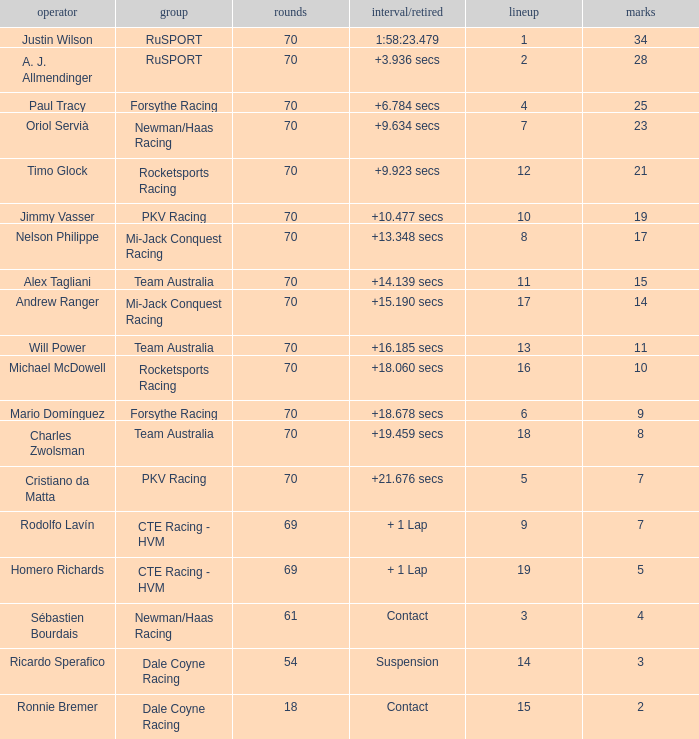Who scored with a grid of 10 and the highest amount of laps? 70.0. Can you give me this table as a dict? {'header': ['operator', 'group', 'rounds', 'interval/retired', 'lineup', 'marks'], 'rows': [['Justin Wilson', 'RuSPORT', '70', '1:58:23.479', '1', '34'], ['A. J. Allmendinger', 'RuSPORT', '70', '+3.936 secs', '2', '28'], ['Paul Tracy', 'Forsythe Racing', '70', '+6.784 secs', '4', '25'], ['Oriol Servià', 'Newman/Haas Racing', '70', '+9.634 secs', '7', '23'], ['Timo Glock', 'Rocketsports Racing', '70', '+9.923 secs', '12', '21'], ['Jimmy Vasser', 'PKV Racing', '70', '+10.477 secs', '10', '19'], ['Nelson Philippe', 'Mi-Jack Conquest Racing', '70', '+13.348 secs', '8', '17'], ['Alex Tagliani', 'Team Australia', '70', '+14.139 secs', '11', '15'], ['Andrew Ranger', 'Mi-Jack Conquest Racing', '70', '+15.190 secs', '17', '14'], ['Will Power', 'Team Australia', '70', '+16.185 secs', '13', '11'], ['Michael McDowell', 'Rocketsports Racing', '70', '+18.060 secs', '16', '10'], ['Mario Domínguez', 'Forsythe Racing', '70', '+18.678 secs', '6', '9'], ['Charles Zwolsman', 'Team Australia', '70', '+19.459 secs', '18', '8'], ['Cristiano da Matta', 'PKV Racing', '70', '+21.676 secs', '5', '7'], ['Rodolfo Lavín', 'CTE Racing - HVM', '69', '+ 1 Lap', '9', '7'], ['Homero Richards', 'CTE Racing - HVM', '69', '+ 1 Lap', '19', '5'], ['Sébastien Bourdais', 'Newman/Haas Racing', '61', 'Contact', '3', '4'], ['Ricardo Sperafico', 'Dale Coyne Racing', '54', 'Suspension', '14', '3'], ['Ronnie Bremer', 'Dale Coyne Racing', '18', 'Contact', '15', '2']]} 